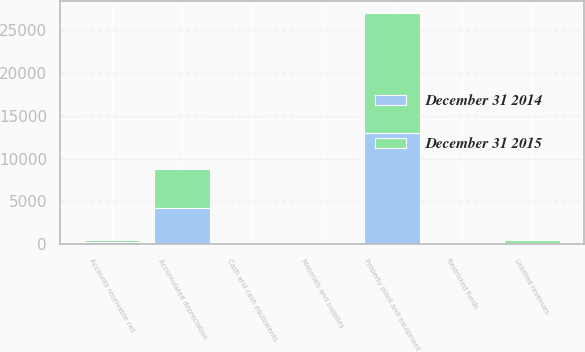Convert chart. <chart><loc_0><loc_0><loc_500><loc_500><stacked_bar_chart><ecel><fcel>Property plant and equipment<fcel>Accumulated depreciation<fcel>Cash and cash equivalents<fcel>Restricted funds<fcel>Accounts receivable net<fcel>Unbilled revenues<fcel>Materials and supplies<nl><fcel>December 31 2015<fcel>13933<fcel>4571<fcel>45<fcel>21<fcel>255<fcel>267<fcel>38<nl><fcel>December 31 2014<fcel>13029<fcel>4240<fcel>23<fcel>14<fcel>232<fcel>221<fcel>37<nl></chart> 